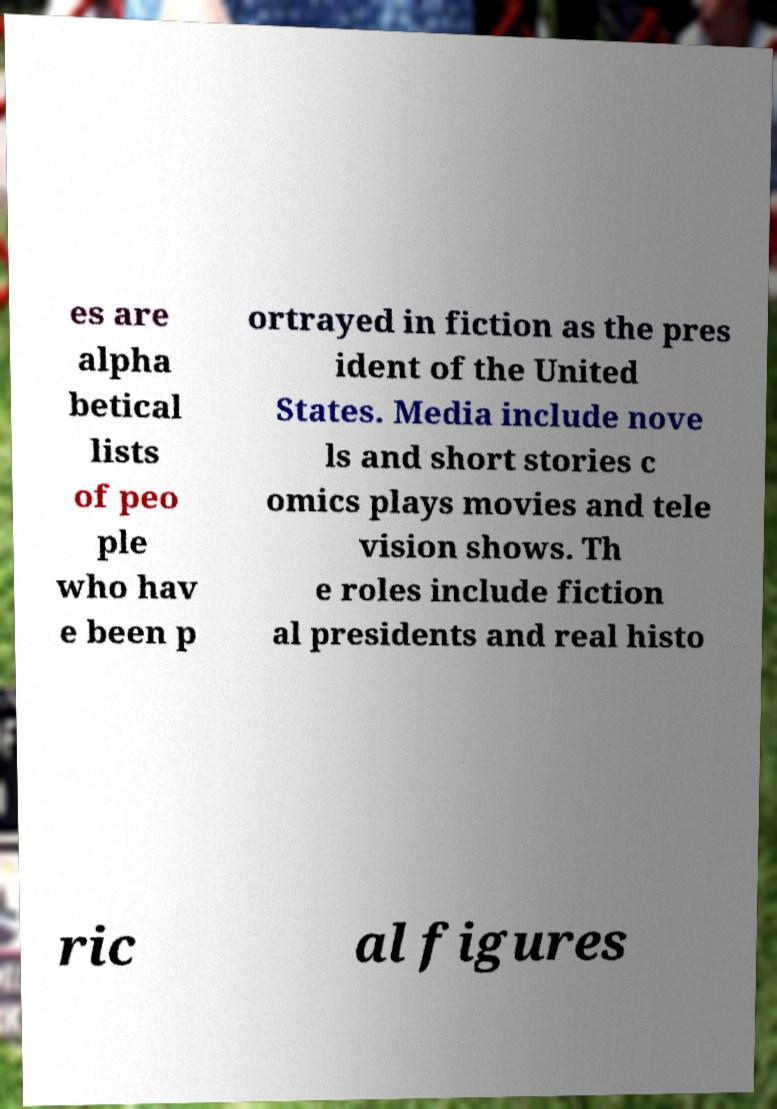Could you extract and type out the text from this image? es are alpha betical lists of peo ple who hav e been p ortrayed in fiction as the pres ident of the United States. Media include nove ls and short stories c omics plays movies and tele vision shows. Th e roles include fiction al presidents and real histo ric al figures 